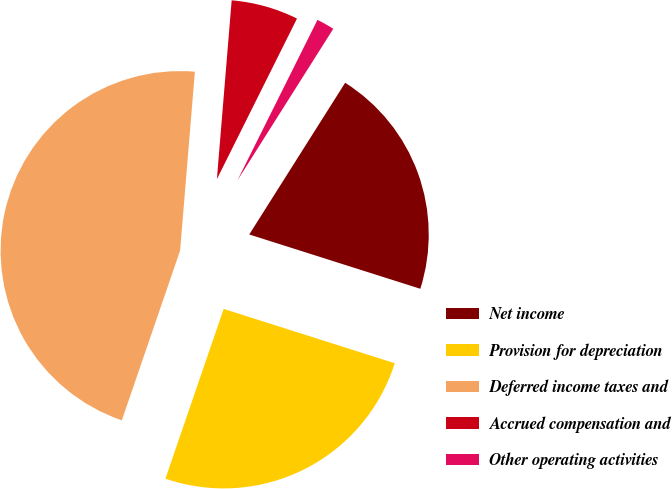Convert chart to OTSL. <chart><loc_0><loc_0><loc_500><loc_500><pie_chart><fcel>Net income<fcel>Provision for depreciation<fcel>Deferred income taxes and<fcel>Accrued compensation and<fcel>Other operating activities<nl><fcel>20.92%<fcel>25.37%<fcel>46.05%<fcel>6.05%<fcel>1.61%<nl></chart> 